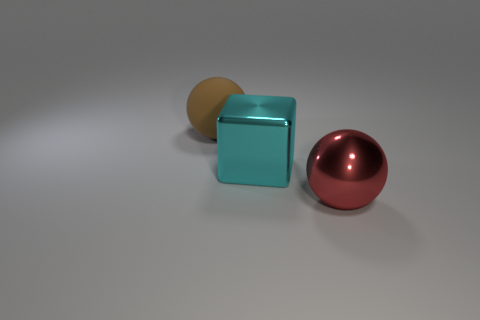Is there any indication of movement or activity in the scene? There is no indication of movement or activity; the objects are stationary, and the composition of the image suggests a still life setup meant for static observation. 